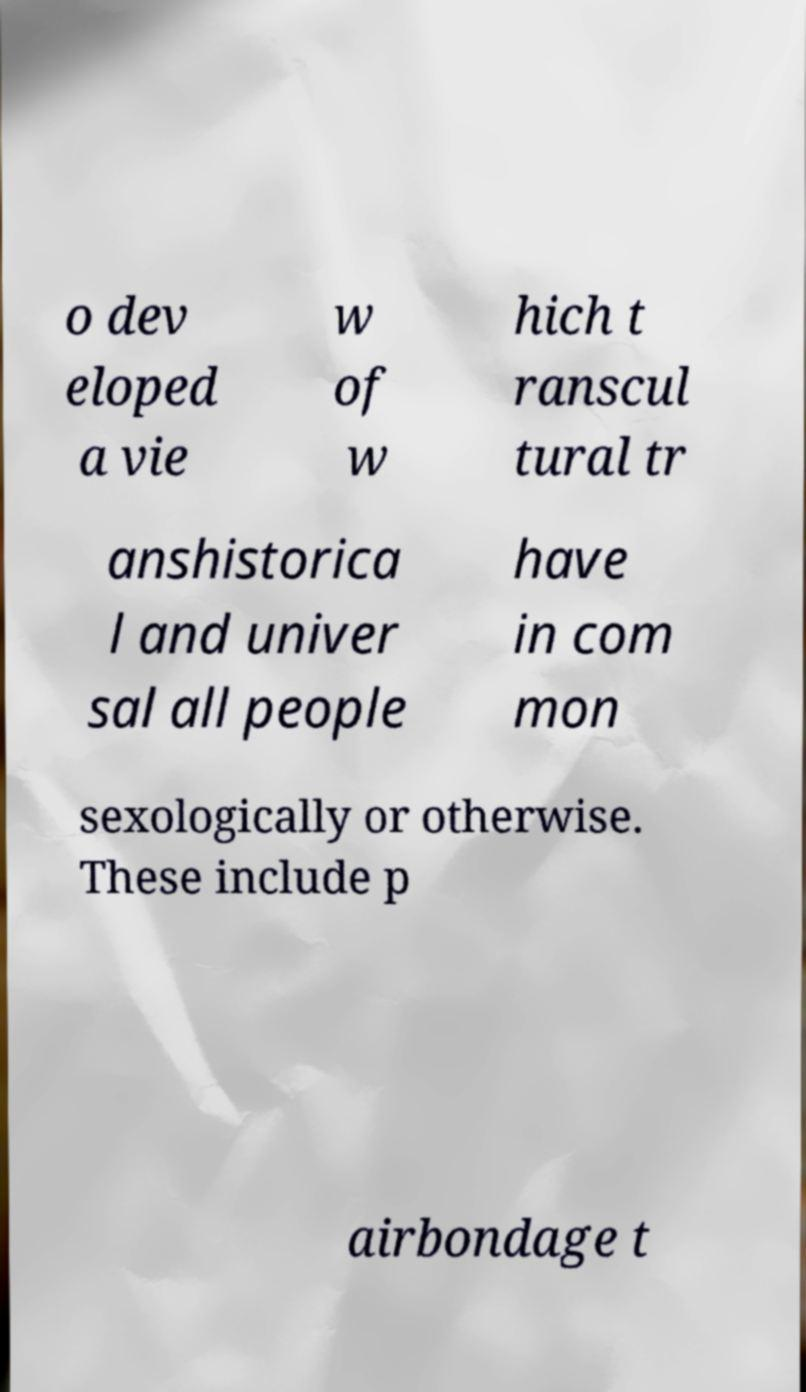Can you read and provide the text displayed in the image?This photo seems to have some interesting text. Can you extract and type it out for me? o dev eloped a vie w of w hich t ranscul tural tr anshistorica l and univer sal all people have in com mon sexologically or otherwise. These include p airbondage t 